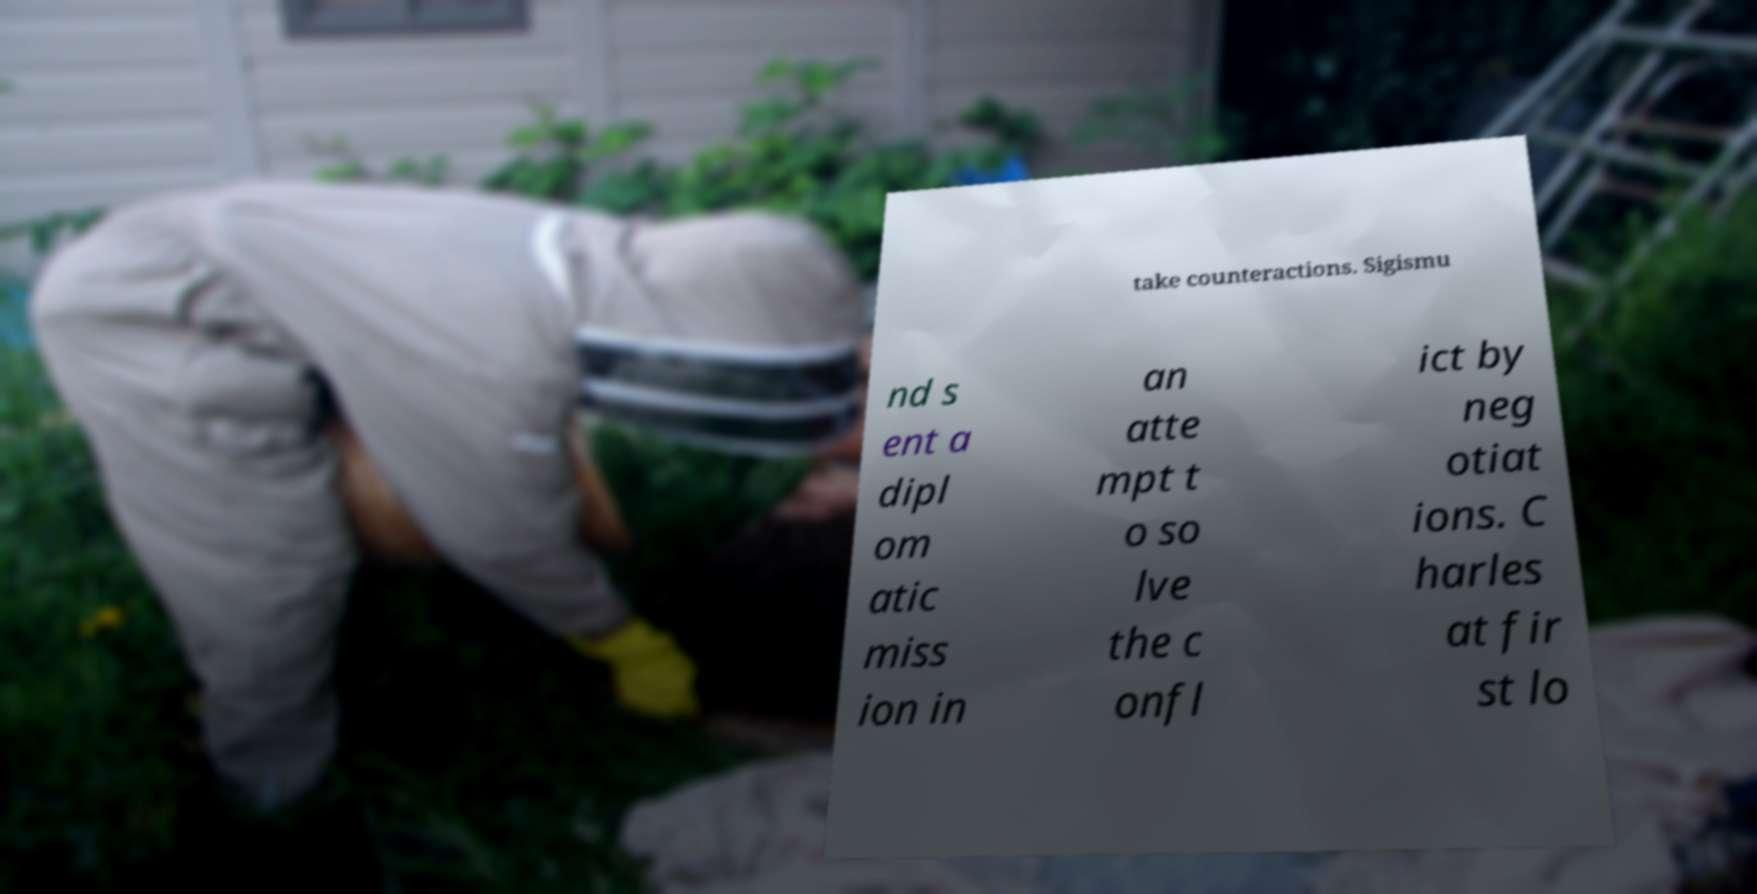Can you read and provide the text displayed in the image?This photo seems to have some interesting text. Can you extract and type it out for me? take counteractions. Sigismu nd s ent a dipl om atic miss ion in an atte mpt t o so lve the c onfl ict by neg otiat ions. C harles at fir st lo 